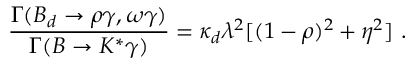Convert formula to latex. <formula><loc_0><loc_0><loc_500><loc_500>\frac { \Gamma ( B _ { d } \to \rho \gamma , \omega \gamma ) } { \Gamma ( B \to K ^ { * } \gamma ) } = \kappa _ { d } \lambda ^ { 2 } [ ( 1 - \rho ) ^ { 2 } + \eta ^ { 2 } ] .</formula> 